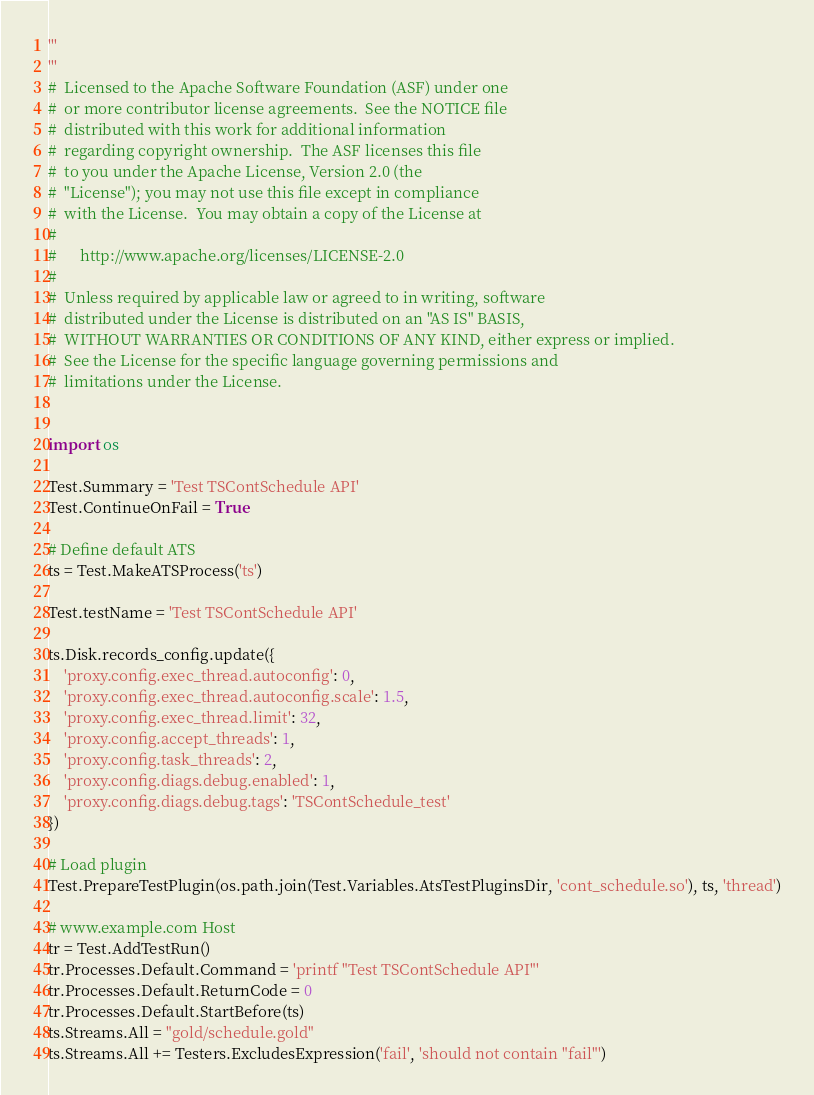Convert code to text. <code><loc_0><loc_0><loc_500><loc_500><_Python_>'''
'''
#  Licensed to the Apache Software Foundation (ASF) under one
#  or more contributor license agreements.  See the NOTICE file
#  distributed with this work for additional information
#  regarding copyright ownership.  The ASF licenses this file
#  to you under the Apache License, Version 2.0 (the
#  "License"); you may not use this file except in compliance
#  with the License.  You may obtain a copy of the License at
#
#      http://www.apache.org/licenses/LICENSE-2.0
#
#  Unless required by applicable law or agreed to in writing, software
#  distributed under the License is distributed on an "AS IS" BASIS,
#  WITHOUT WARRANTIES OR CONDITIONS OF ANY KIND, either express or implied.
#  See the License for the specific language governing permissions and
#  limitations under the License.


import os

Test.Summary = 'Test TSContSchedule API'
Test.ContinueOnFail = True

# Define default ATS
ts = Test.MakeATSProcess('ts')

Test.testName = 'Test TSContSchedule API'

ts.Disk.records_config.update({
    'proxy.config.exec_thread.autoconfig': 0,
    'proxy.config.exec_thread.autoconfig.scale': 1.5,
    'proxy.config.exec_thread.limit': 32,
    'proxy.config.accept_threads': 1,
    'proxy.config.task_threads': 2,
    'proxy.config.diags.debug.enabled': 1,
    'proxy.config.diags.debug.tags': 'TSContSchedule_test'
})

# Load plugin
Test.PrepareTestPlugin(os.path.join(Test.Variables.AtsTestPluginsDir, 'cont_schedule.so'), ts, 'thread')

# www.example.com Host
tr = Test.AddTestRun()
tr.Processes.Default.Command = 'printf "Test TSContSchedule API"'
tr.Processes.Default.ReturnCode = 0
tr.Processes.Default.StartBefore(ts)
ts.Streams.All = "gold/schedule.gold"
ts.Streams.All += Testers.ExcludesExpression('fail', 'should not contain "fail"')
</code> 